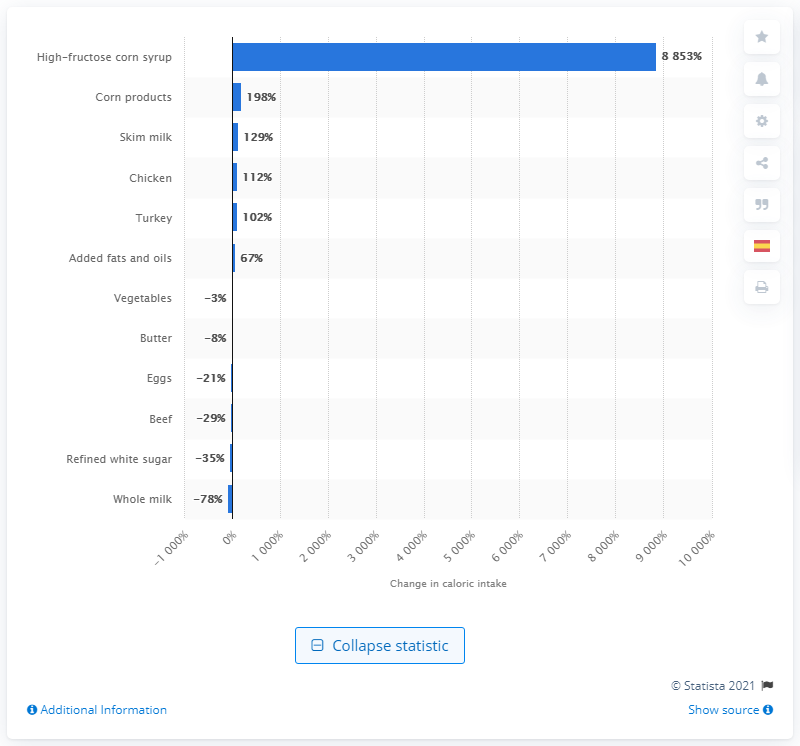Specify some key components in this picture. Corn products have become a staple in the diet of the average U.S. citizen. Since 1970, the amount of caloric intake from corn products among U.S. citizens has significantly increased. 